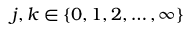Convert formula to latex. <formula><loc_0><loc_0><loc_500><loc_500>j , k \in \{ 0 , 1 , 2 , \dots , \infty \}</formula> 